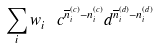<formula> <loc_0><loc_0><loc_500><loc_500>\sum _ { i } w ^ { \ } _ { i } \, c ^ { \overline { n } ^ { ( c ) } _ { i } - n ^ { ( c ) } _ { i } } d ^ { \overline { n } ^ { ( d ) } _ { i } - n ^ { ( d ) } _ { i } }</formula> 